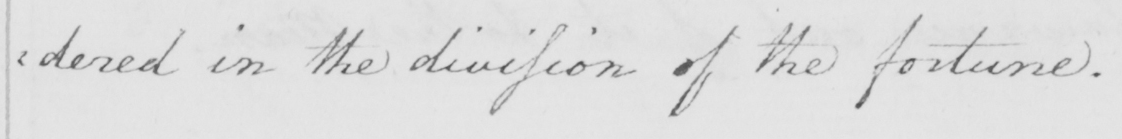What does this handwritten line say? : dered in the divission of the fortune . 